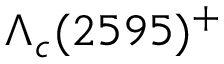<formula> <loc_0><loc_0><loc_500><loc_500>\Lambda _ { c } ( 2 5 9 5 ) ^ { + }</formula> 